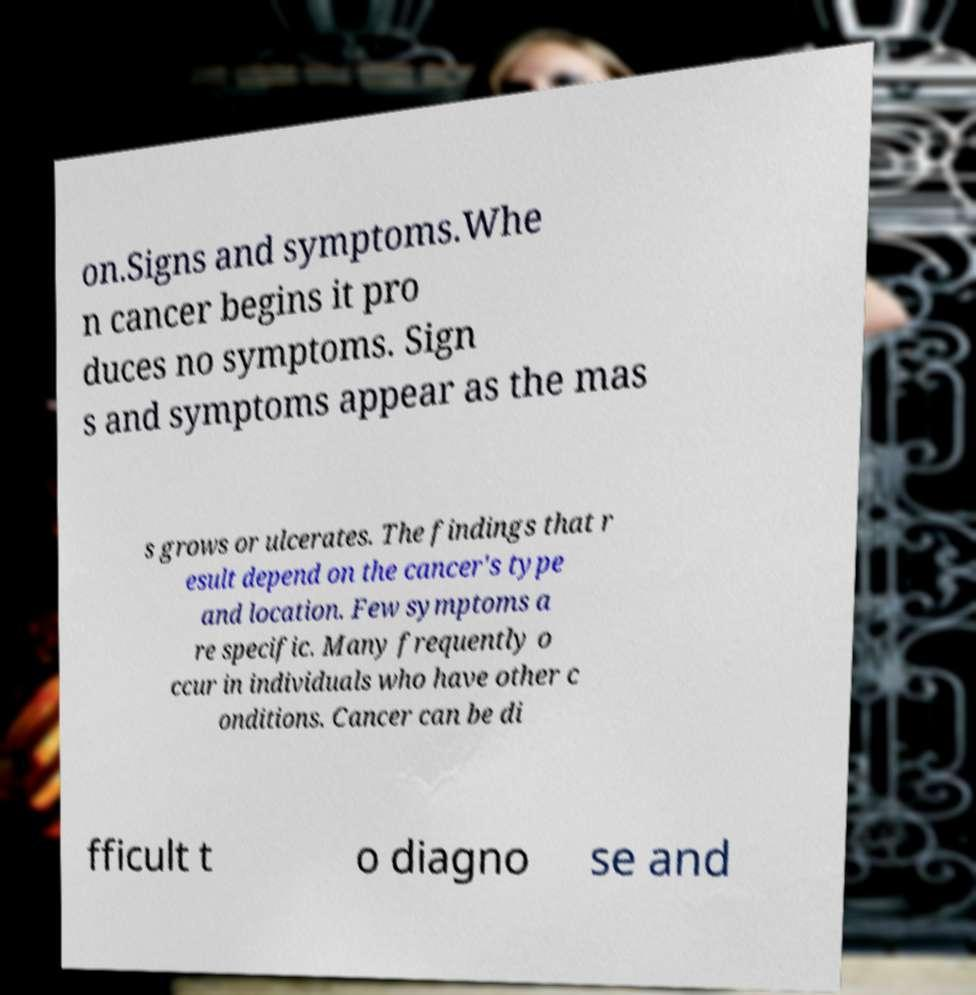I need the written content from this picture converted into text. Can you do that? on.Signs and symptoms.Whe n cancer begins it pro duces no symptoms. Sign s and symptoms appear as the mas s grows or ulcerates. The findings that r esult depend on the cancer's type and location. Few symptoms a re specific. Many frequently o ccur in individuals who have other c onditions. Cancer can be di fficult t o diagno se and 